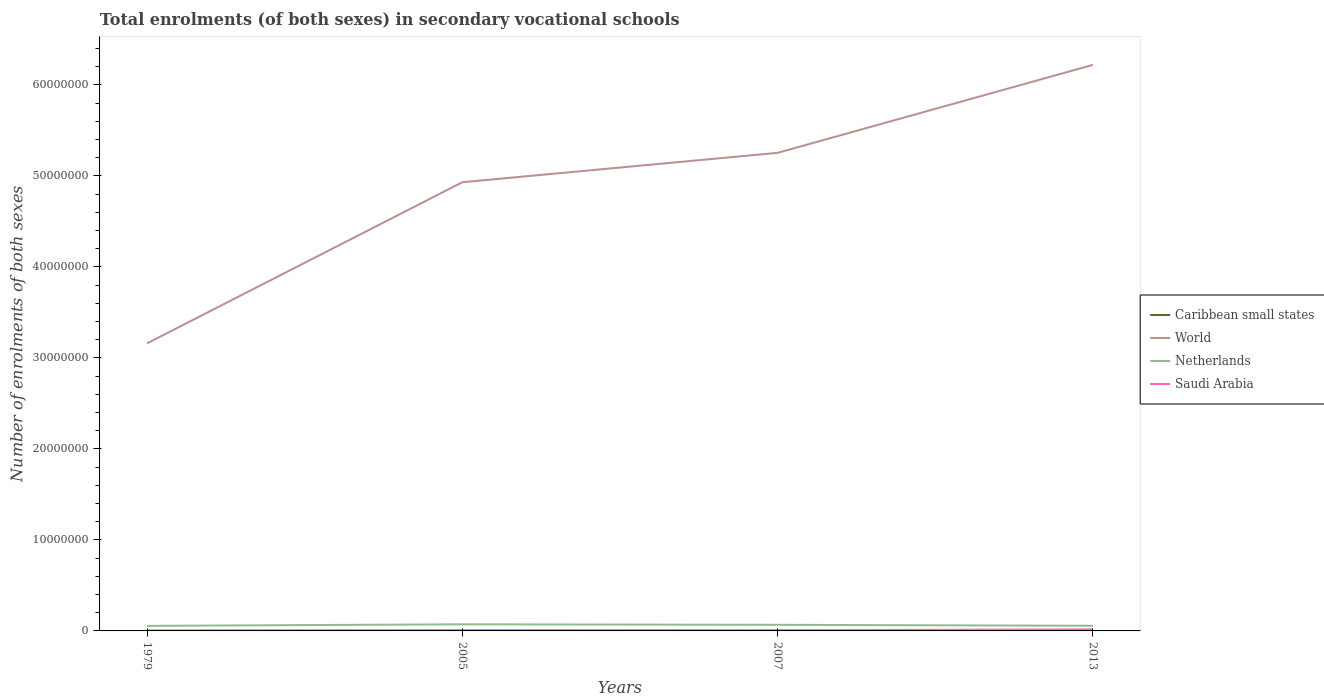Is the number of lines equal to the number of legend labels?
Your response must be concise. Yes. Across all years, what is the maximum number of enrolments in secondary schools in Netherlands?
Offer a terse response. 5.56e+05. In which year was the number of enrolments in secondary schools in Netherlands maximum?
Offer a very short reply. 1979. What is the total number of enrolments in secondary schools in World in the graph?
Provide a succinct answer. -3.23e+06. What is the difference between the highest and the second highest number of enrolments in secondary schools in World?
Your response must be concise. 3.06e+07. Is the number of enrolments in secondary schools in World strictly greater than the number of enrolments in secondary schools in Saudi Arabia over the years?
Your answer should be compact. No. How many years are there in the graph?
Keep it short and to the point. 4. What is the difference between two consecutive major ticks on the Y-axis?
Make the answer very short. 1.00e+07. Does the graph contain any zero values?
Provide a succinct answer. No. What is the title of the graph?
Make the answer very short. Total enrolments (of both sexes) in secondary vocational schools. What is the label or title of the Y-axis?
Make the answer very short. Number of enrolments of both sexes. What is the Number of enrolments of both sexes in Caribbean small states in 1979?
Offer a very short reply. 2.62e+04. What is the Number of enrolments of both sexes of World in 1979?
Give a very brief answer. 3.16e+07. What is the Number of enrolments of both sexes of Netherlands in 1979?
Give a very brief answer. 5.56e+05. What is the Number of enrolments of both sexes in Saudi Arabia in 1979?
Your answer should be very brief. 2.26e+04. What is the Number of enrolments of both sexes in Caribbean small states in 2005?
Provide a succinct answer. 3.32e+04. What is the Number of enrolments of both sexes in World in 2005?
Provide a short and direct response. 4.93e+07. What is the Number of enrolments of both sexes in Netherlands in 2005?
Your response must be concise. 7.26e+05. What is the Number of enrolments of both sexes of Saudi Arabia in 2005?
Give a very brief answer. 8.56e+04. What is the Number of enrolments of both sexes of Caribbean small states in 2007?
Make the answer very short. 3.33e+04. What is the Number of enrolments of both sexes of World in 2007?
Provide a short and direct response. 5.25e+07. What is the Number of enrolments of both sexes of Netherlands in 2007?
Offer a terse response. 6.71e+05. What is the Number of enrolments of both sexes of Saudi Arabia in 2007?
Provide a succinct answer. 7.96e+04. What is the Number of enrolments of both sexes of Caribbean small states in 2013?
Offer a terse response. 2.25e+04. What is the Number of enrolments of both sexes in World in 2013?
Your answer should be compact. 6.22e+07. What is the Number of enrolments of both sexes of Netherlands in 2013?
Ensure brevity in your answer.  5.65e+05. What is the Number of enrolments of both sexes of Saudi Arabia in 2013?
Your response must be concise. 1.77e+05. Across all years, what is the maximum Number of enrolments of both sexes in Caribbean small states?
Offer a terse response. 3.33e+04. Across all years, what is the maximum Number of enrolments of both sexes of World?
Make the answer very short. 6.22e+07. Across all years, what is the maximum Number of enrolments of both sexes in Netherlands?
Provide a short and direct response. 7.26e+05. Across all years, what is the maximum Number of enrolments of both sexes in Saudi Arabia?
Provide a succinct answer. 1.77e+05. Across all years, what is the minimum Number of enrolments of both sexes of Caribbean small states?
Offer a terse response. 2.25e+04. Across all years, what is the minimum Number of enrolments of both sexes of World?
Give a very brief answer. 3.16e+07. Across all years, what is the minimum Number of enrolments of both sexes of Netherlands?
Provide a short and direct response. 5.56e+05. Across all years, what is the minimum Number of enrolments of both sexes in Saudi Arabia?
Provide a short and direct response. 2.26e+04. What is the total Number of enrolments of both sexes in Caribbean small states in the graph?
Give a very brief answer. 1.15e+05. What is the total Number of enrolments of both sexes of World in the graph?
Your answer should be compact. 1.96e+08. What is the total Number of enrolments of both sexes of Netherlands in the graph?
Offer a very short reply. 2.52e+06. What is the total Number of enrolments of both sexes of Saudi Arabia in the graph?
Your answer should be very brief. 3.65e+05. What is the difference between the Number of enrolments of both sexes of Caribbean small states in 1979 and that in 2005?
Your response must be concise. -7010.29. What is the difference between the Number of enrolments of both sexes in World in 1979 and that in 2005?
Provide a short and direct response. -1.77e+07. What is the difference between the Number of enrolments of both sexes in Netherlands in 1979 and that in 2005?
Your response must be concise. -1.69e+05. What is the difference between the Number of enrolments of both sexes in Saudi Arabia in 1979 and that in 2005?
Offer a terse response. -6.30e+04. What is the difference between the Number of enrolments of both sexes in Caribbean small states in 1979 and that in 2007?
Provide a short and direct response. -7156.12. What is the difference between the Number of enrolments of both sexes in World in 1979 and that in 2007?
Make the answer very short. -2.09e+07. What is the difference between the Number of enrolments of both sexes of Netherlands in 1979 and that in 2007?
Offer a very short reply. -1.15e+05. What is the difference between the Number of enrolments of both sexes in Saudi Arabia in 1979 and that in 2007?
Offer a very short reply. -5.70e+04. What is the difference between the Number of enrolments of both sexes in Caribbean small states in 1979 and that in 2013?
Make the answer very short. 3686.84. What is the difference between the Number of enrolments of both sexes in World in 1979 and that in 2013?
Make the answer very short. -3.06e+07. What is the difference between the Number of enrolments of both sexes of Netherlands in 1979 and that in 2013?
Your answer should be very brief. -9163. What is the difference between the Number of enrolments of both sexes of Saudi Arabia in 1979 and that in 2013?
Offer a very short reply. -1.54e+05. What is the difference between the Number of enrolments of both sexes in Caribbean small states in 2005 and that in 2007?
Your answer should be very brief. -145.83. What is the difference between the Number of enrolments of both sexes of World in 2005 and that in 2007?
Your answer should be compact. -3.23e+06. What is the difference between the Number of enrolments of both sexes of Netherlands in 2005 and that in 2007?
Offer a very short reply. 5.43e+04. What is the difference between the Number of enrolments of both sexes in Saudi Arabia in 2005 and that in 2007?
Provide a short and direct response. 6018. What is the difference between the Number of enrolments of both sexes of Caribbean small states in 2005 and that in 2013?
Give a very brief answer. 1.07e+04. What is the difference between the Number of enrolments of both sexes of World in 2005 and that in 2013?
Provide a succinct answer. -1.29e+07. What is the difference between the Number of enrolments of both sexes of Netherlands in 2005 and that in 2013?
Provide a succinct answer. 1.60e+05. What is the difference between the Number of enrolments of both sexes of Saudi Arabia in 2005 and that in 2013?
Offer a terse response. -9.14e+04. What is the difference between the Number of enrolments of both sexes of Caribbean small states in 2007 and that in 2013?
Offer a terse response. 1.08e+04. What is the difference between the Number of enrolments of both sexes of World in 2007 and that in 2013?
Provide a short and direct response. -9.66e+06. What is the difference between the Number of enrolments of both sexes in Netherlands in 2007 and that in 2013?
Provide a short and direct response. 1.06e+05. What is the difference between the Number of enrolments of both sexes in Saudi Arabia in 2007 and that in 2013?
Your response must be concise. -9.74e+04. What is the difference between the Number of enrolments of both sexes of Caribbean small states in 1979 and the Number of enrolments of both sexes of World in 2005?
Keep it short and to the point. -4.93e+07. What is the difference between the Number of enrolments of both sexes of Caribbean small states in 1979 and the Number of enrolments of both sexes of Netherlands in 2005?
Your answer should be compact. -6.99e+05. What is the difference between the Number of enrolments of both sexes of Caribbean small states in 1979 and the Number of enrolments of both sexes of Saudi Arabia in 2005?
Give a very brief answer. -5.94e+04. What is the difference between the Number of enrolments of both sexes in World in 1979 and the Number of enrolments of both sexes in Netherlands in 2005?
Your response must be concise. 3.09e+07. What is the difference between the Number of enrolments of both sexes of World in 1979 and the Number of enrolments of both sexes of Saudi Arabia in 2005?
Your answer should be compact. 3.15e+07. What is the difference between the Number of enrolments of both sexes of Netherlands in 1979 and the Number of enrolments of both sexes of Saudi Arabia in 2005?
Provide a short and direct response. 4.71e+05. What is the difference between the Number of enrolments of both sexes in Caribbean small states in 1979 and the Number of enrolments of both sexes in World in 2007?
Your response must be concise. -5.25e+07. What is the difference between the Number of enrolments of both sexes of Caribbean small states in 1979 and the Number of enrolments of both sexes of Netherlands in 2007?
Provide a short and direct response. -6.45e+05. What is the difference between the Number of enrolments of both sexes of Caribbean small states in 1979 and the Number of enrolments of both sexes of Saudi Arabia in 2007?
Provide a short and direct response. -5.34e+04. What is the difference between the Number of enrolments of both sexes of World in 1979 and the Number of enrolments of both sexes of Netherlands in 2007?
Ensure brevity in your answer.  3.09e+07. What is the difference between the Number of enrolments of both sexes of World in 1979 and the Number of enrolments of both sexes of Saudi Arabia in 2007?
Provide a short and direct response. 3.15e+07. What is the difference between the Number of enrolments of both sexes of Netherlands in 1979 and the Number of enrolments of both sexes of Saudi Arabia in 2007?
Make the answer very short. 4.77e+05. What is the difference between the Number of enrolments of both sexes in Caribbean small states in 1979 and the Number of enrolments of both sexes in World in 2013?
Your answer should be very brief. -6.22e+07. What is the difference between the Number of enrolments of both sexes in Caribbean small states in 1979 and the Number of enrolments of both sexes in Netherlands in 2013?
Ensure brevity in your answer.  -5.39e+05. What is the difference between the Number of enrolments of both sexes in Caribbean small states in 1979 and the Number of enrolments of both sexes in Saudi Arabia in 2013?
Ensure brevity in your answer.  -1.51e+05. What is the difference between the Number of enrolments of both sexes of World in 1979 and the Number of enrolments of both sexes of Netherlands in 2013?
Ensure brevity in your answer.  3.10e+07. What is the difference between the Number of enrolments of both sexes in World in 1979 and the Number of enrolments of both sexes in Saudi Arabia in 2013?
Provide a succinct answer. 3.14e+07. What is the difference between the Number of enrolments of both sexes in Netherlands in 1979 and the Number of enrolments of both sexes in Saudi Arabia in 2013?
Your answer should be compact. 3.79e+05. What is the difference between the Number of enrolments of both sexes of Caribbean small states in 2005 and the Number of enrolments of both sexes of World in 2007?
Provide a short and direct response. -5.25e+07. What is the difference between the Number of enrolments of both sexes of Caribbean small states in 2005 and the Number of enrolments of both sexes of Netherlands in 2007?
Your answer should be compact. -6.38e+05. What is the difference between the Number of enrolments of both sexes in Caribbean small states in 2005 and the Number of enrolments of both sexes in Saudi Arabia in 2007?
Keep it short and to the point. -4.64e+04. What is the difference between the Number of enrolments of both sexes of World in 2005 and the Number of enrolments of both sexes of Netherlands in 2007?
Offer a very short reply. 4.86e+07. What is the difference between the Number of enrolments of both sexes in World in 2005 and the Number of enrolments of both sexes in Saudi Arabia in 2007?
Offer a terse response. 4.92e+07. What is the difference between the Number of enrolments of both sexes of Netherlands in 2005 and the Number of enrolments of both sexes of Saudi Arabia in 2007?
Ensure brevity in your answer.  6.46e+05. What is the difference between the Number of enrolments of both sexes of Caribbean small states in 2005 and the Number of enrolments of both sexes of World in 2013?
Offer a terse response. -6.22e+07. What is the difference between the Number of enrolments of both sexes in Caribbean small states in 2005 and the Number of enrolments of both sexes in Netherlands in 2013?
Offer a terse response. -5.32e+05. What is the difference between the Number of enrolments of both sexes of Caribbean small states in 2005 and the Number of enrolments of both sexes of Saudi Arabia in 2013?
Ensure brevity in your answer.  -1.44e+05. What is the difference between the Number of enrolments of both sexes of World in 2005 and the Number of enrolments of both sexes of Netherlands in 2013?
Provide a short and direct response. 4.87e+07. What is the difference between the Number of enrolments of both sexes in World in 2005 and the Number of enrolments of both sexes in Saudi Arabia in 2013?
Make the answer very short. 4.91e+07. What is the difference between the Number of enrolments of both sexes of Netherlands in 2005 and the Number of enrolments of both sexes of Saudi Arabia in 2013?
Provide a short and direct response. 5.49e+05. What is the difference between the Number of enrolments of both sexes of Caribbean small states in 2007 and the Number of enrolments of both sexes of World in 2013?
Keep it short and to the point. -6.22e+07. What is the difference between the Number of enrolments of both sexes in Caribbean small states in 2007 and the Number of enrolments of both sexes in Netherlands in 2013?
Ensure brevity in your answer.  -5.32e+05. What is the difference between the Number of enrolments of both sexes of Caribbean small states in 2007 and the Number of enrolments of both sexes of Saudi Arabia in 2013?
Keep it short and to the point. -1.44e+05. What is the difference between the Number of enrolments of both sexes of World in 2007 and the Number of enrolments of both sexes of Netherlands in 2013?
Offer a terse response. 5.20e+07. What is the difference between the Number of enrolments of both sexes in World in 2007 and the Number of enrolments of both sexes in Saudi Arabia in 2013?
Your response must be concise. 5.24e+07. What is the difference between the Number of enrolments of both sexes in Netherlands in 2007 and the Number of enrolments of both sexes in Saudi Arabia in 2013?
Provide a succinct answer. 4.94e+05. What is the average Number of enrolments of both sexes in Caribbean small states per year?
Provide a short and direct response. 2.88e+04. What is the average Number of enrolments of both sexes in World per year?
Provide a succinct answer. 4.89e+07. What is the average Number of enrolments of both sexes in Netherlands per year?
Make the answer very short. 6.30e+05. What is the average Number of enrolments of both sexes of Saudi Arabia per year?
Your answer should be compact. 9.12e+04. In the year 1979, what is the difference between the Number of enrolments of both sexes in Caribbean small states and Number of enrolments of both sexes in World?
Offer a terse response. -3.16e+07. In the year 1979, what is the difference between the Number of enrolments of both sexes in Caribbean small states and Number of enrolments of both sexes in Netherlands?
Make the answer very short. -5.30e+05. In the year 1979, what is the difference between the Number of enrolments of both sexes of Caribbean small states and Number of enrolments of both sexes of Saudi Arabia?
Provide a succinct answer. 3540.18. In the year 1979, what is the difference between the Number of enrolments of both sexes in World and Number of enrolments of both sexes in Netherlands?
Your answer should be very brief. 3.10e+07. In the year 1979, what is the difference between the Number of enrolments of both sexes in World and Number of enrolments of both sexes in Saudi Arabia?
Your answer should be compact. 3.16e+07. In the year 1979, what is the difference between the Number of enrolments of both sexes in Netherlands and Number of enrolments of both sexes in Saudi Arabia?
Give a very brief answer. 5.34e+05. In the year 2005, what is the difference between the Number of enrolments of both sexes of Caribbean small states and Number of enrolments of both sexes of World?
Your answer should be very brief. -4.93e+07. In the year 2005, what is the difference between the Number of enrolments of both sexes in Caribbean small states and Number of enrolments of both sexes in Netherlands?
Offer a terse response. -6.92e+05. In the year 2005, what is the difference between the Number of enrolments of both sexes of Caribbean small states and Number of enrolments of both sexes of Saudi Arabia?
Offer a terse response. -5.24e+04. In the year 2005, what is the difference between the Number of enrolments of both sexes in World and Number of enrolments of both sexes in Netherlands?
Offer a very short reply. 4.86e+07. In the year 2005, what is the difference between the Number of enrolments of both sexes of World and Number of enrolments of both sexes of Saudi Arabia?
Provide a short and direct response. 4.92e+07. In the year 2005, what is the difference between the Number of enrolments of both sexes of Netherlands and Number of enrolments of both sexes of Saudi Arabia?
Give a very brief answer. 6.40e+05. In the year 2007, what is the difference between the Number of enrolments of both sexes in Caribbean small states and Number of enrolments of both sexes in World?
Ensure brevity in your answer.  -5.25e+07. In the year 2007, what is the difference between the Number of enrolments of both sexes of Caribbean small states and Number of enrolments of both sexes of Netherlands?
Keep it short and to the point. -6.38e+05. In the year 2007, what is the difference between the Number of enrolments of both sexes of Caribbean small states and Number of enrolments of both sexes of Saudi Arabia?
Your answer should be compact. -4.63e+04. In the year 2007, what is the difference between the Number of enrolments of both sexes of World and Number of enrolments of both sexes of Netherlands?
Keep it short and to the point. 5.19e+07. In the year 2007, what is the difference between the Number of enrolments of both sexes of World and Number of enrolments of both sexes of Saudi Arabia?
Give a very brief answer. 5.24e+07. In the year 2007, what is the difference between the Number of enrolments of both sexes of Netherlands and Number of enrolments of both sexes of Saudi Arabia?
Keep it short and to the point. 5.92e+05. In the year 2013, what is the difference between the Number of enrolments of both sexes in Caribbean small states and Number of enrolments of both sexes in World?
Provide a short and direct response. -6.22e+07. In the year 2013, what is the difference between the Number of enrolments of both sexes in Caribbean small states and Number of enrolments of both sexes in Netherlands?
Your response must be concise. -5.43e+05. In the year 2013, what is the difference between the Number of enrolments of both sexes of Caribbean small states and Number of enrolments of both sexes of Saudi Arabia?
Your answer should be compact. -1.55e+05. In the year 2013, what is the difference between the Number of enrolments of both sexes in World and Number of enrolments of both sexes in Netherlands?
Provide a succinct answer. 6.16e+07. In the year 2013, what is the difference between the Number of enrolments of both sexes in World and Number of enrolments of both sexes in Saudi Arabia?
Give a very brief answer. 6.20e+07. In the year 2013, what is the difference between the Number of enrolments of both sexes in Netherlands and Number of enrolments of both sexes in Saudi Arabia?
Keep it short and to the point. 3.88e+05. What is the ratio of the Number of enrolments of both sexes in Caribbean small states in 1979 to that in 2005?
Keep it short and to the point. 0.79. What is the ratio of the Number of enrolments of both sexes in World in 1979 to that in 2005?
Your answer should be compact. 0.64. What is the ratio of the Number of enrolments of both sexes of Netherlands in 1979 to that in 2005?
Offer a very short reply. 0.77. What is the ratio of the Number of enrolments of both sexes in Saudi Arabia in 1979 to that in 2005?
Keep it short and to the point. 0.26. What is the ratio of the Number of enrolments of both sexes of Caribbean small states in 1979 to that in 2007?
Your answer should be very brief. 0.79. What is the ratio of the Number of enrolments of both sexes in World in 1979 to that in 2007?
Provide a succinct answer. 0.6. What is the ratio of the Number of enrolments of both sexes in Netherlands in 1979 to that in 2007?
Ensure brevity in your answer.  0.83. What is the ratio of the Number of enrolments of both sexes in Saudi Arabia in 1979 to that in 2007?
Your response must be concise. 0.28. What is the ratio of the Number of enrolments of both sexes in Caribbean small states in 1979 to that in 2013?
Give a very brief answer. 1.16. What is the ratio of the Number of enrolments of both sexes in World in 1979 to that in 2013?
Your response must be concise. 0.51. What is the ratio of the Number of enrolments of both sexes in Netherlands in 1979 to that in 2013?
Your answer should be compact. 0.98. What is the ratio of the Number of enrolments of both sexes of Saudi Arabia in 1979 to that in 2013?
Offer a very short reply. 0.13. What is the ratio of the Number of enrolments of both sexes of World in 2005 to that in 2007?
Provide a short and direct response. 0.94. What is the ratio of the Number of enrolments of both sexes in Netherlands in 2005 to that in 2007?
Offer a terse response. 1.08. What is the ratio of the Number of enrolments of both sexes of Saudi Arabia in 2005 to that in 2007?
Ensure brevity in your answer.  1.08. What is the ratio of the Number of enrolments of both sexes of Caribbean small states in 2005 to that in 2013?
Give a very brief answer. 1.48. What is the ratio of the Number of enrolments of both sexes of World in 2005 to that in 2013?
Make the answer very short. 0.79. What is the ratio of the Number of enrolments of both sexes in Netherlands in 2005 to that in 2013?
Provide a succinct answer. 1.28. What is the ratio of the Number of enrolments of both sexes of Saudi Arabia in 2005 to that in 2013?
Offer a very short reply. 0.48. What is the ratio of the Number of enrolments of both sexes of Caribbean small states in 2007 to that in 2013?
Keep it short and to the point. 1.48. What is the ratio of the Number of enrolments of both sexes in World in 2007 to that in 2013?
Your answer should be very brief. 0.84. What is the ratio of the Number of enrolments of both sexes in Netherlands in 2007 to that in 2013?
Make the answer very short. 1.19. What is the ratio of the Number of enrolments of both sexes of Saudi Arabia in 2007 to that in 2013?
Make the answer very short. 0.45. What is the difference between the highest and the second highest Number of enrolments of both sexes in Caribbean small states?
Your answer should be very brief. 145.83. What is the difference between the highest and the second highest Number of enrolments of both sexes of World?
Ensure brevity in your answer.  9.66e+06. What is the difference between the highest and the second highest Number of enrolments of both sexes in Netherlands?
Keep it short and to the point. 5.43e+04. What is the difference between the highest and the second highest Number of enrolments of both sexes of Saudi Arabia?
Your answer should be compact. 9.14e+04. What is the difference between the highest and the lowest Number of enrolments of both sexes in Caribbean small states?
Ensure brevity in your answer.  1.08e+04. What is the difference between the highest and the lowest Number of enrolments of both sexes in World?
Ensure brevity in your answer.  3.06e+07. What is the difference between the highest and the lowest Number of enrolments of both sexes of Netherlands?
Make the answer very short. 1.69e+05. What is the difference between the highest and the lowest Number of enrolments of both sexes of Saudi Arabia?
Your answer should be very brief. 1.54e+05. 